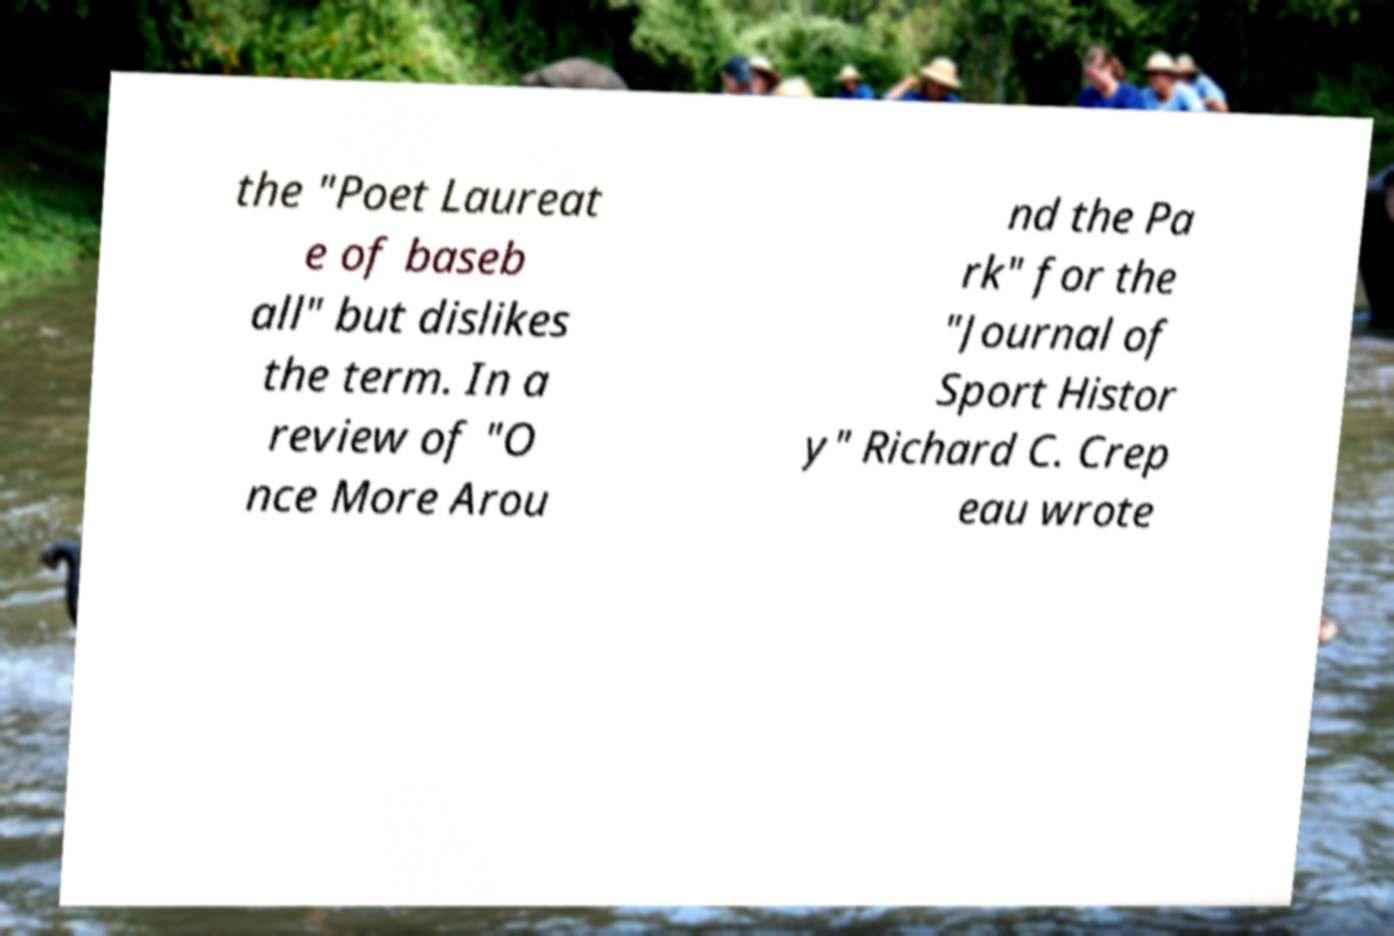I need the written content from this picture converted into text. Can you do that? the "Poet Laureat e of baseb all" but dislikes the term. In a review of "O nce More Arou nd the Pa rk" for the "Journal of Sport Histor y" Richard C. Crep eau wrote 